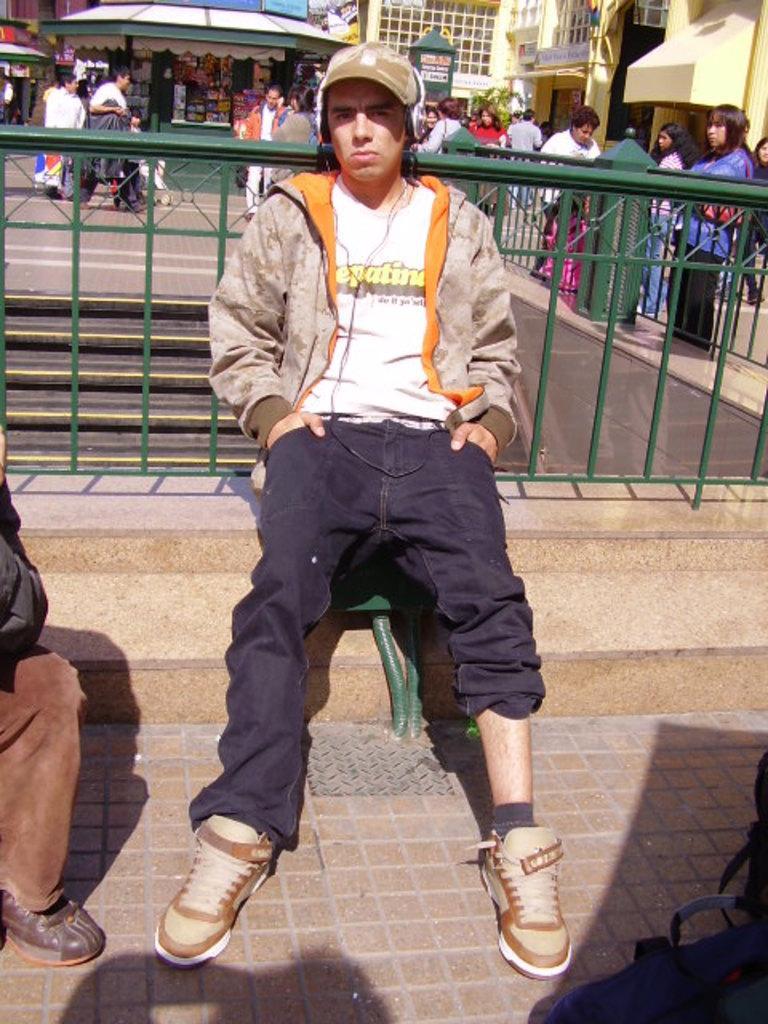Could you give a brief overview of what you see in this image? In this given picture, We can see a person sitting, listening to music and there is an iron fence which is build has a boundary wall towards the right, We can see a couple of people standing after that behind the person, We can a small stall few people standing and carrying. 